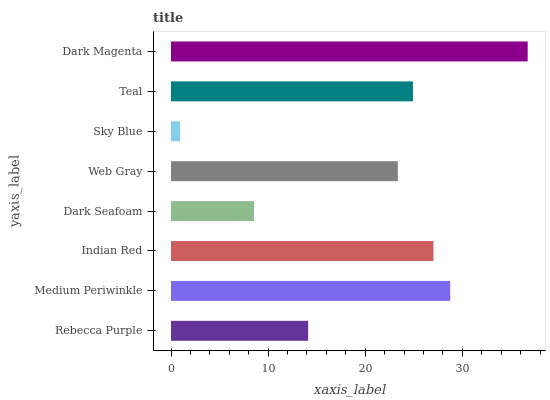Is Sky Blue the minimum?
Answer yes or no. Yes. Is Dark Magenta the maximum?
Answer yes or no. Yes. Is Medium Periwinkle the minimum?
Answer yes or no. No. Is Medium Periwinkle the maximum?
Answer yes or no. No. Is Medium Periwinkle greater than Rebecca Purple?
Answer yes or no. Yes. Is Rebecca Purple less than Medium Periwinkle?
Answer yes or no. Yes. Is Rebecca Purple greater than Medium Periwinkle?
Answer yes or no. No. Is Medium Periwinkle less than Rebecca Purple?
Answer yes or no. No. Is Teal the high median?
Answer yes or no. Yes. Is Web Gray the low median?
Answer yes or no. Yes. Is Indian Red the high median?
Answer yes or no. No. Is Indian Red the low median?
Answer yes or no. No. 